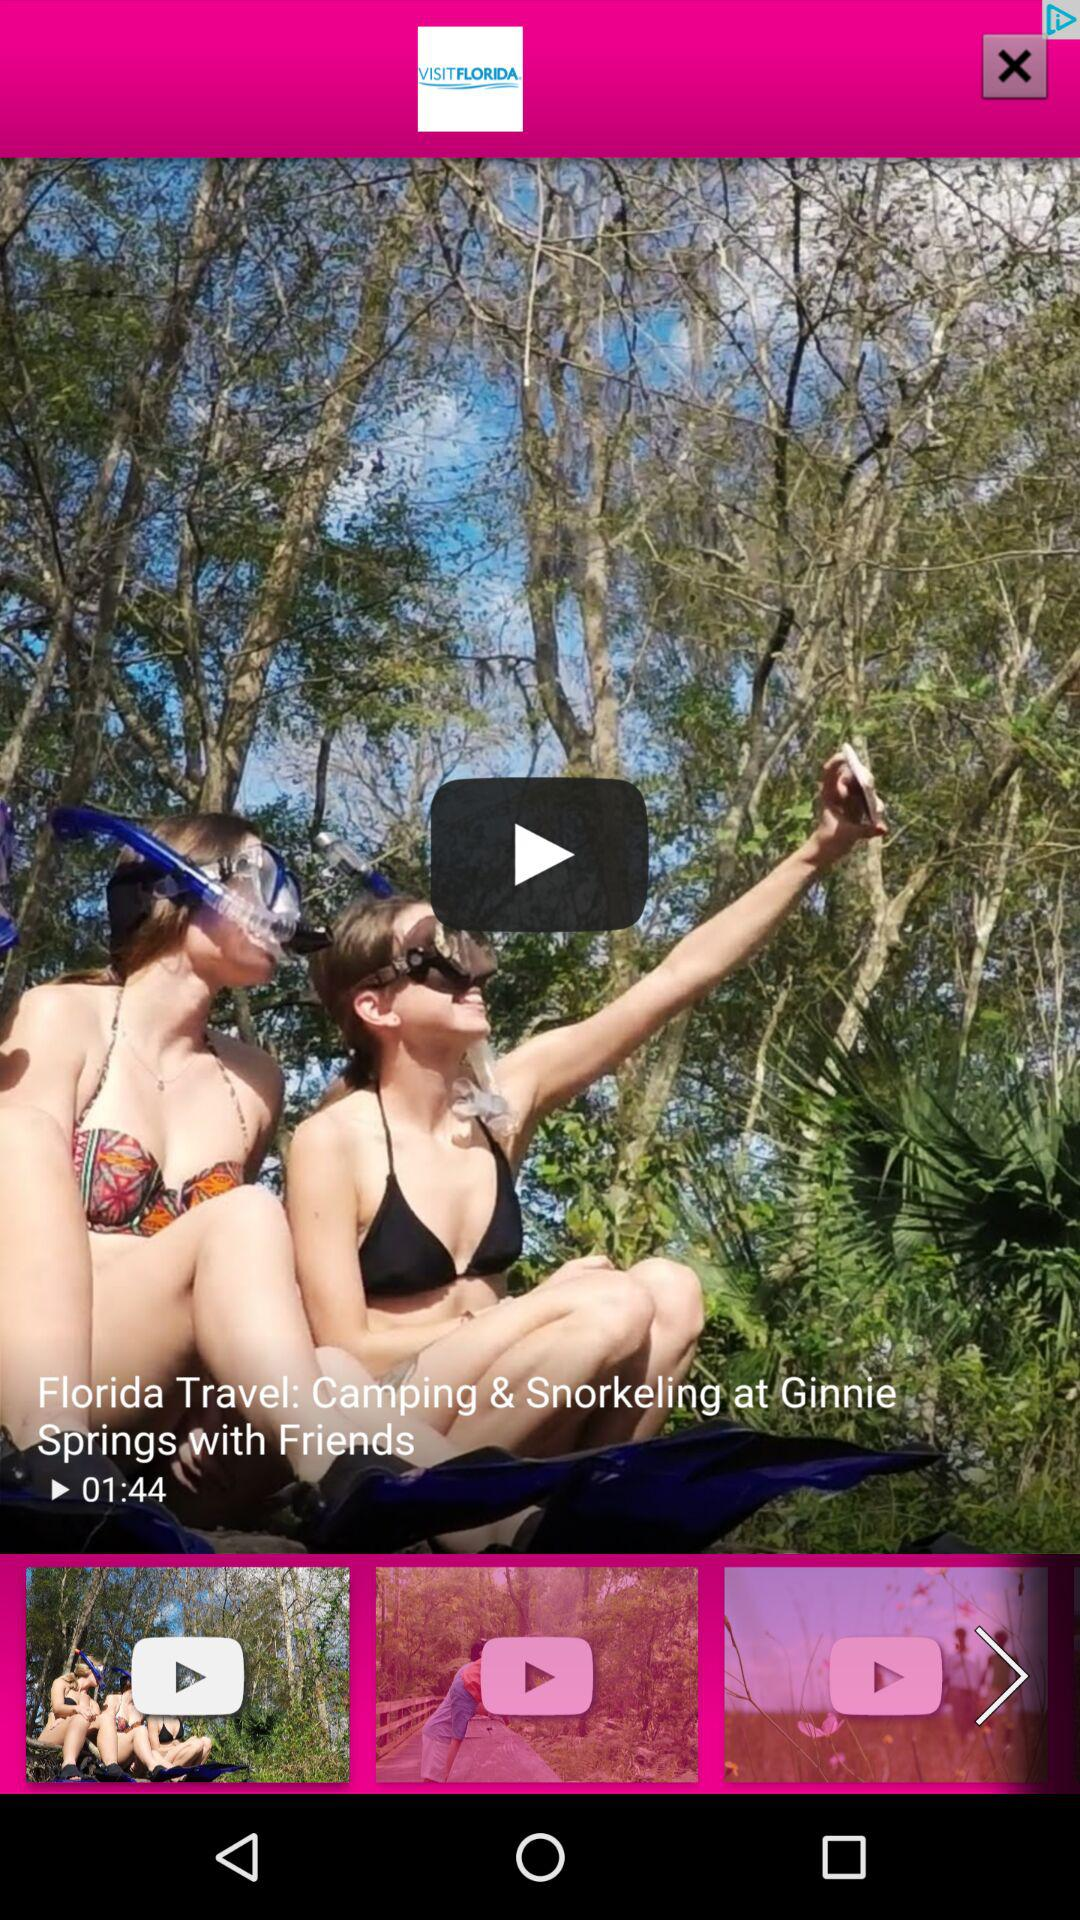What is the length of the video? The length of the video is 1 minutes 44 seconds. 